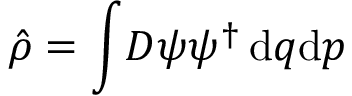Convert formula to latex. <formula><loc_0><loc_0><loc_500><loc_500>\hat { \rho } = \int \, D \psi \psi ^ { \dagger } \, d q d p</formula> 